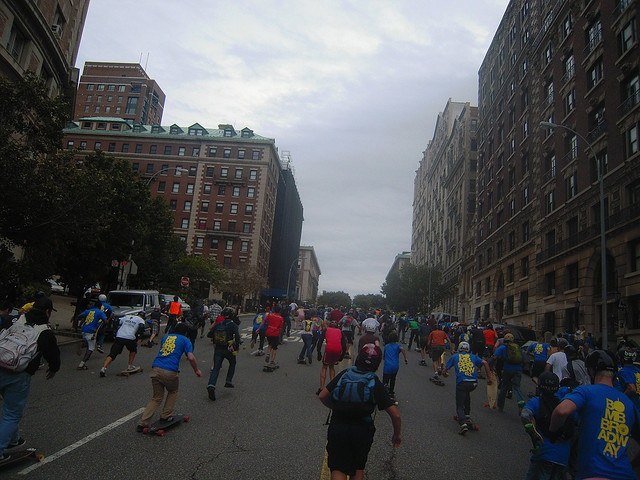Describe the objects in this image and their specific colors. I can see people in black, navy, olive, and maroon tones, people in black, maroon, navy, and blue tones, people in black and navy tones, people in black, navy, gray, and darkgreen tones, and people in black, navy, and maroon tones in this image. 